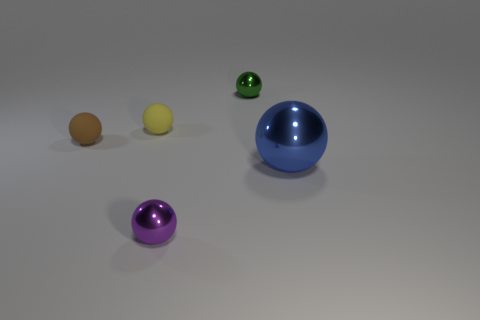Subtract all small yellow balls. How many balls are left? 4 Subtract all brown spheres. How many spheres are left? 4 Add 2 matte spheres. How many objects exist? 7 Subtract all gray balls. Subtract all green cylinders. How many balls are left? 5 Add 5 large red metallic cylinders. How many large red metallic cylinders exist? 5 Subtract 0 purple cubes. How many objects are left? 5 Subtract all tiny gray matte things. Subtract all tiny purple shiny things. How many objects are left? 4 Add 2 small purple metal objects. How many small purple metal objects are left? 3 